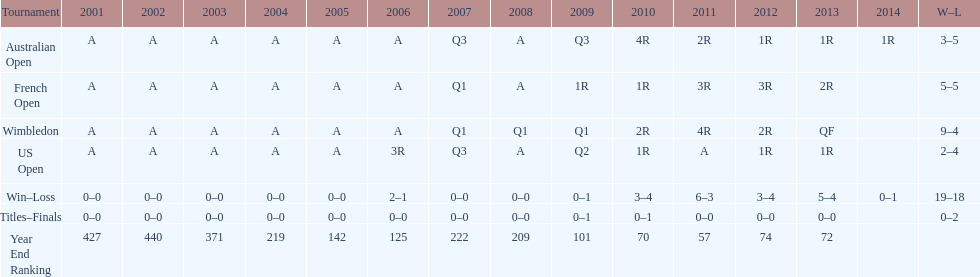Which tournament has the largest total win record? Wimbledon. 